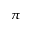<formula> <loc_0><loc_0><loc_500><loc_500>\pi</formula> 